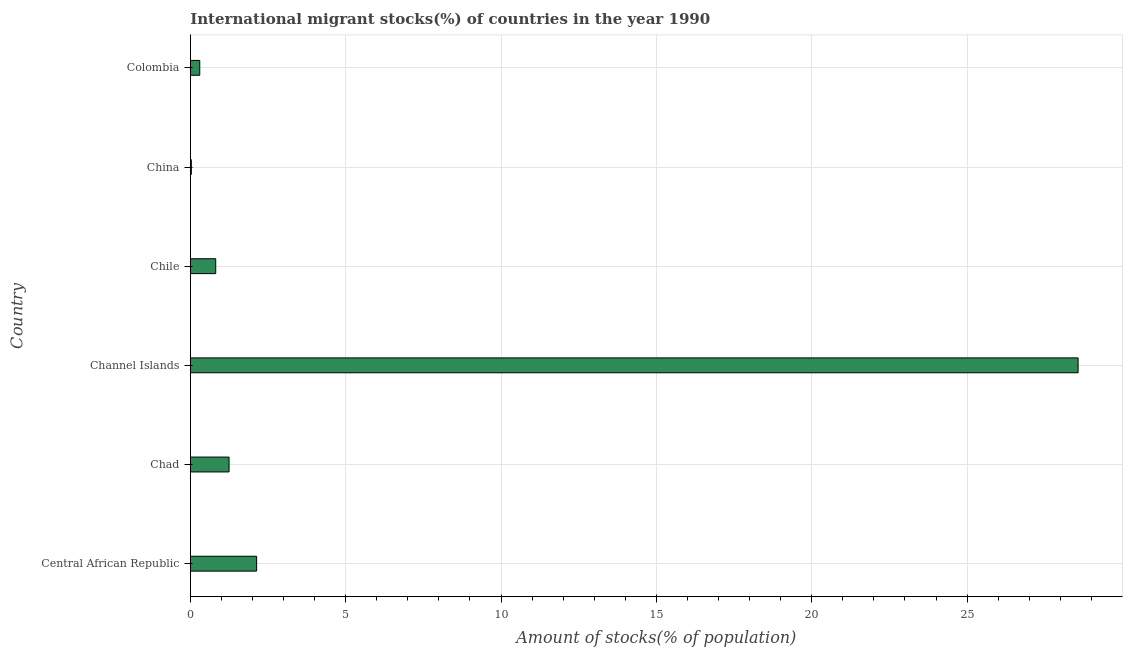What is the title of the graph?
Make the answer very short. International migrant stocks(%) of countries in the year 1990. What is the label or title of the X-axis?
Keep it short and to the point. Amount of stocks(% of population). What is the label or title of the Y-axis?
Keep it short and to the point. Country. What is the number of international migrant stocks in Channel Islands?
Provide a short and direct response. 28.57. Across all countries, what is the maximum number of international migrant stocks?
Give a very brief answer. 28.57. Across all countries, what is the minimum number of international migrant stocks?
Keep it short and to the point. 0.03. In which country was the number of international migrant stocks maximum?
Provide a short and direct response. Channel Islands. In which country was the number of international migrant stocks minimum?
Give a very brief answer. China. What is the sum of the number of international migrant stocks?
Offer a terse response. 33.11. What is the difference between the number of international migrant stocks in Chile and Colombia?
Your answer should be compact. 0.51. What is the average number of international migrant stocks per country?
Your response must be concise. 5.52. What is the median number of international migrant stocks?
Offer a very short reply. 1.03. In how many countries, is the number of international migrant stocks greater than 28 %?
Provide a succinct answer. 1. What is the ratio of the number of international migrant stocks in Chad to that in Channel Islands?
Keep it short and to the point. 0.04. What is the difference between the highest and the second highest number of international migrant stocks?
Your answer should be very brief. 26.44. Is the sum of the number of international migrant stocks in Chad and Colombia greater than the maximum number of international migrant stocks across all countries?
Provide a succinct answer. No. What is the difference between the highest and the lowest number of international migrant stocks?
Your answer should be compact. 28.54. In how many countries, is the number of international migrant stocks greater than the average number of international migrant stocks taken over all countries?
Your answer should be compact. 1. What is the Amount of stocks(% of population) of Central African Republic?
Give a very brief answer. 2.13. What is the Amount of stocks(% of population) in Chad?
Offer a terse response. 1.25. What is the Amount of stocks(% of population) in Channel Islands?
Offer a very short reply. 28.57. What is the Amount of stocks(% of population) in Chile?
Offer a very short reply. 0.82. What is the Amount of stocks(% of population) of China?
Your answer should be compact. 0.03. What is the Amount of stocks(% of population) of Colombia?
Provide a short and direct response. 0.3. What is the difference between the Amount of stocks(% of population) in Central African Republic and Chad?
Ensure brevity in your answer.  0.89. What is the difference between the Amount of stocks(% of population) in Central African Republic and Channel Islands?
Ensure brevity in your answer.  -26.44. What is the difference between the Amount of stocks(% of population) in Central African Republic and Chile?
Offer a terse response. 1.32. What is the difference between the Amount of stocks(% of population) in Central African Republic and China?
Your answer should be compact. 2.1. What is the difference between the Amount of stocks(% of population) in Central African Republic and Colombia?
Ensure brevity in your answer.  1.83. What is the difference between the Amount of stocks(% of population) in Chad and Channel Islands?
Your answer should be compact. -27.32. What is the difference between the Amount of stocks(% of population) in Chad and Chile?
Provide a short and direct response. 0.43. What is the difference between the Amount of stocks(% of population) in Chad and China?
Your response must be concise. 1.21. What is the difference between the Amount of stocks(% of population) in Chad and Colombia?
Your answer should be compact. 0.94. What is the difference between the Amount of stocks(% of population) in Channel Islands and Chile?
Your response must be concise. 27.75. What is the difference between the Amount of stocks(% of population) in Channel Islands and China?
Ensure brevity in your answer.  28.54. What is the difference between the Amount of stocks(% of population) in Channel Islands and Colombia?
Offer a very short reply. 28.27. What is the difference between the Amount of stocks(% of population) in Chile and China?
Make the answer very short. 0.78. What is the difference between the Amount of stocks(% of population) in Chile and Colombia?
Provide a short and direct response. 0.51. What is the difference between the Amount of stocks(% of population) in China and Colombia?
Your response must be concise. -0.27. What is the ratio of the Amount of stocks(% of population) in Central African Republic to that in Chad?
Your response must be concise. 1.71. What is the ratio of the Amount of stocks(% of population) in Central African Republic to that in Channel Islands?
Make the answer very short. 0.07. What is the ratio of the Amount of stocks(% of population) in Central African Republic to that in Chile?
Provide a short and direct response. 2.61. What is the ratio of the Amount of stocks(% of population) in Central African Republic to that in China?
Offer a terse response. 64.39. What is the ratio of the Amount of stocks(% of population) in Central African Republic to that in Colombia?
Provide a short and direct response. 7.02. What is the ratio of the Amount of stocks(% of population) in Chad to that in Channel Islands?
Offer a terse response. 0.04. What is the ratio of the Amount of stocks(% of population) in Chad to that in Chile?
Offer a very short reply. 1.52. What is the ratio of the Amount of stocks(% of population) in Chad to that in China?
Offer a terse response. 37.63. What is the ratio of the Amount of stocks(% of population) in Chad to that in Colombia?
Provide a succinct answer. 4.1. What is the ratio of the Amount of stocks(% of population) in Channel Islands to that in Chile?
Ensure brevity in your answer.  34.93. What is the ratio of the Amount of stocks(% of population) in Channel Islands to that in China?
Offer a terse response. 861.77. What is the ratio of the Amount of stocks(% of population) in Channel Islands to that in Colombia?
Ensure brevity in your answer.  93.9. What is the ratio of the Amount of stocks(% of population) in Chile to that in China?
Provide a succinct answer. 24.67. What is the ratio of the Amount of stocks(% of population) in Chile to that in Colombia?
Offer a terse response. 2.69. What is the ratio of the Amount of stocks(% of population) in China to that in Colombia?
Keep it short and to the point. 0.11. 